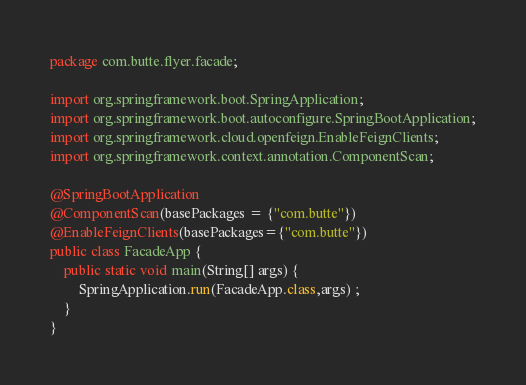Convert code to text. <code><loc_0><loc_0><loc_500><loc_500><_Java_>package com.butte.flyer.facade;

import org.springframework.boot.SpringApplication;
import org.springframework.boot.autoconfigure.SpringBootApplication;
import org.springframework.cloud.openfeign.EnableFeignClients;
import org.springframework.context.annotation.ComponentScan;

@SpringBootApplication
@ComponentScan(basePackages = {"com.butte"})
@EnableFeignClients(basePackages={"com.butte"})
public class FacadeApp {
    public static void main(String[] args) {
        SpringApplication.run(FacadeApp.class,args) ;
    }
}</code> 